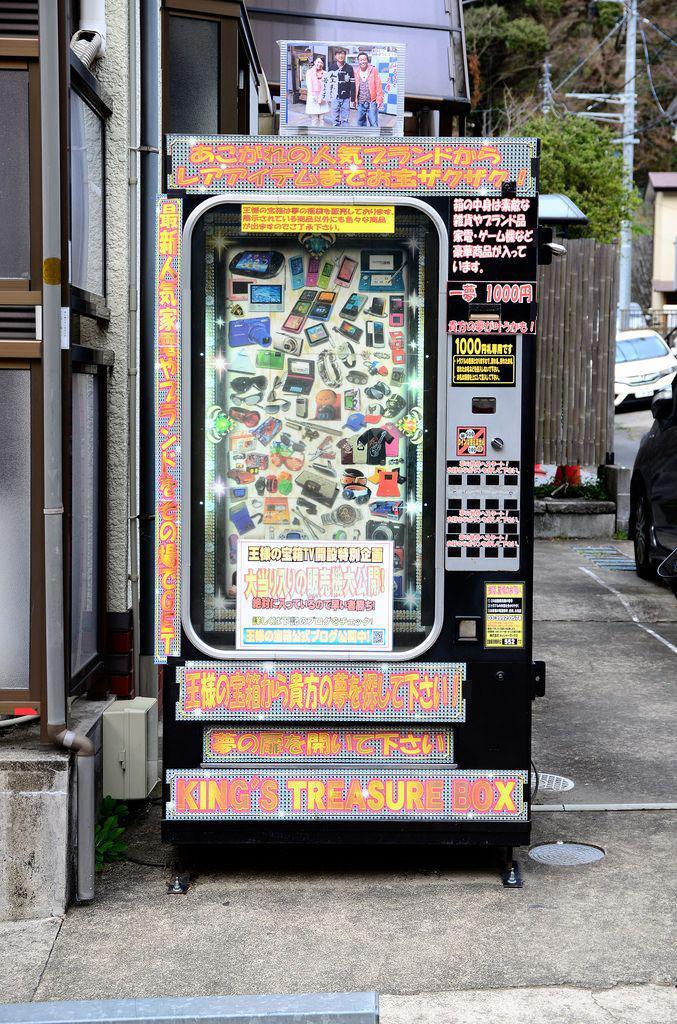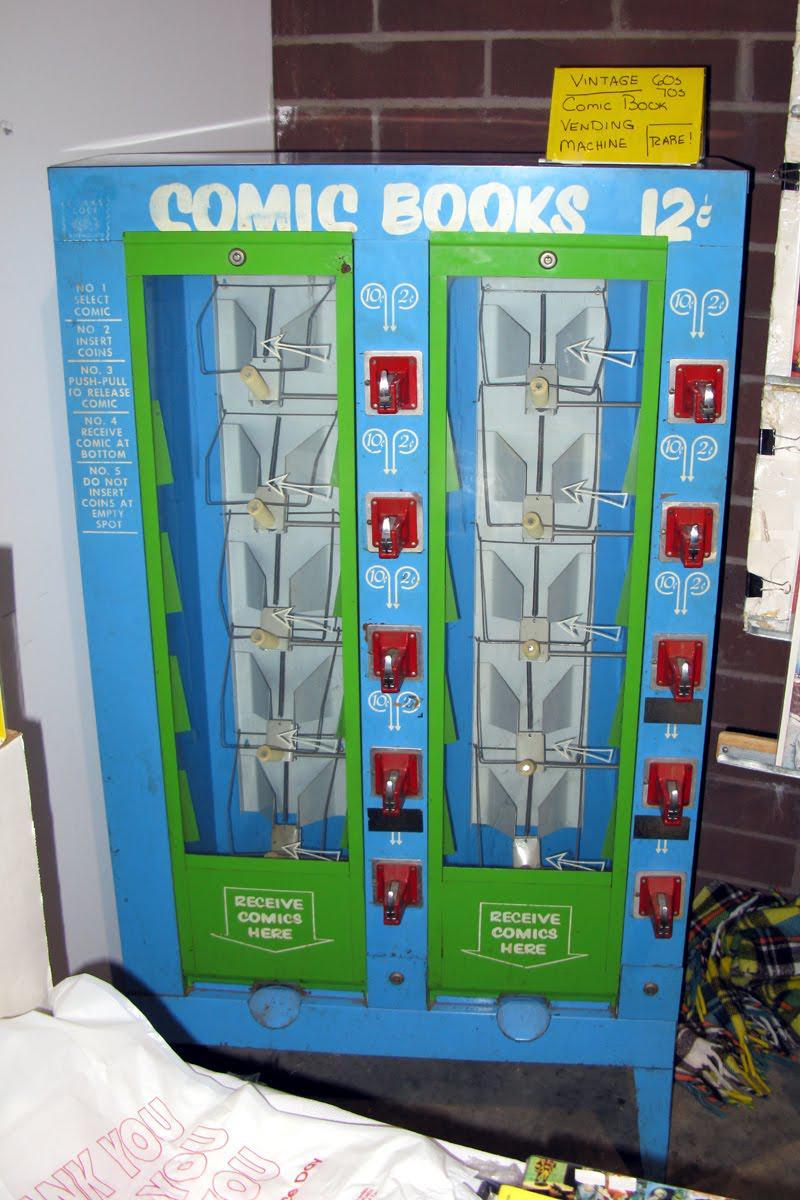The first image is the image on the left, the second image is the image on the right. For the images shown, is this caption "There is a red vending machine in one of the images" true? Answer yes or no. No. The first image is the image on the left, the second image is the image on the right. Given the left and right images, does the statement "One of the images contains more than one vending machine." hold true? Answer yes or no. No. 